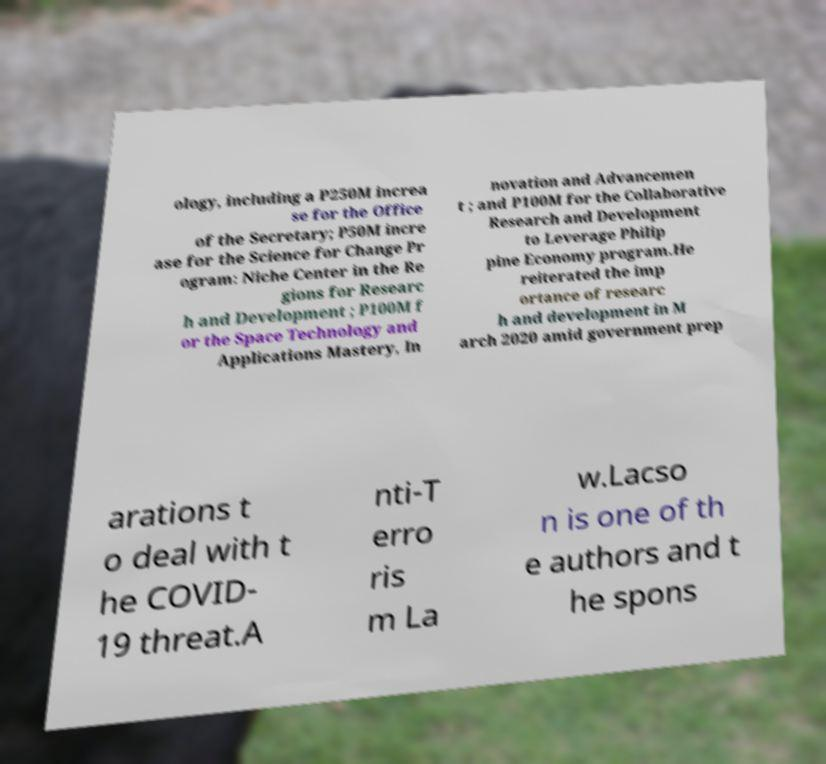Can you read and provide the text displayed in the image?This photo seems to have some interesting text. Can you extract and type it out for me? ology, including a P250M increa se for the Office of the Secretary; P50M incre ase for the Science for Change Pr ogram: Niche Center in the Re gions for Researc h and Development ; P100M f or the Space Technology and Applications Mastery, In novation and Advancemen t ; and P100M for the Collaborative Research and Development to Leverage Philip pine Economy program.He reiterated the imp ortance of researc h and development in M arch 2020 amid government prep arations t o deal with t he COVID- 19 threat.A nti-T erro ris m La w.Lacso n is one of th e authors and t he spons 